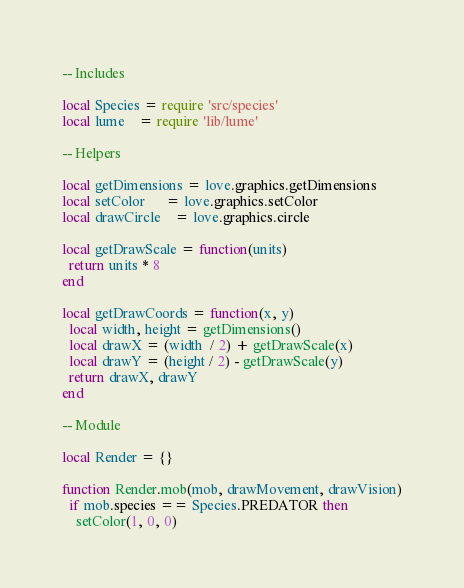Convert code to text. <code><loc_0><loc_0><loc_500><loc_500><_Lua_>-- Includes

local Species = require 'src/species'
local lume    = require 'lib/lume'

-- Helpers

local getDimensions = love.graphics.getDimensions
local setColor      = love.graphics.setColor
local drawCircle    = love.graphics.circle

local getDrawScale = function(units)
  return units * 8
end

local getDrawCoords = function(x, y)
  local width, height = getDimensions()
  local drawX = (width  / 2) + getDrawScale(x)
  local drawY = (height / 2) - getDrawScale(y)
  return drawX, drawY
end

-- Module

local Render = {}

function Render.mob(mob, drawMovement, drawVision)
  if mob.species == Species.PREDATOR then
    setColor(1, 0, 0)</code> 